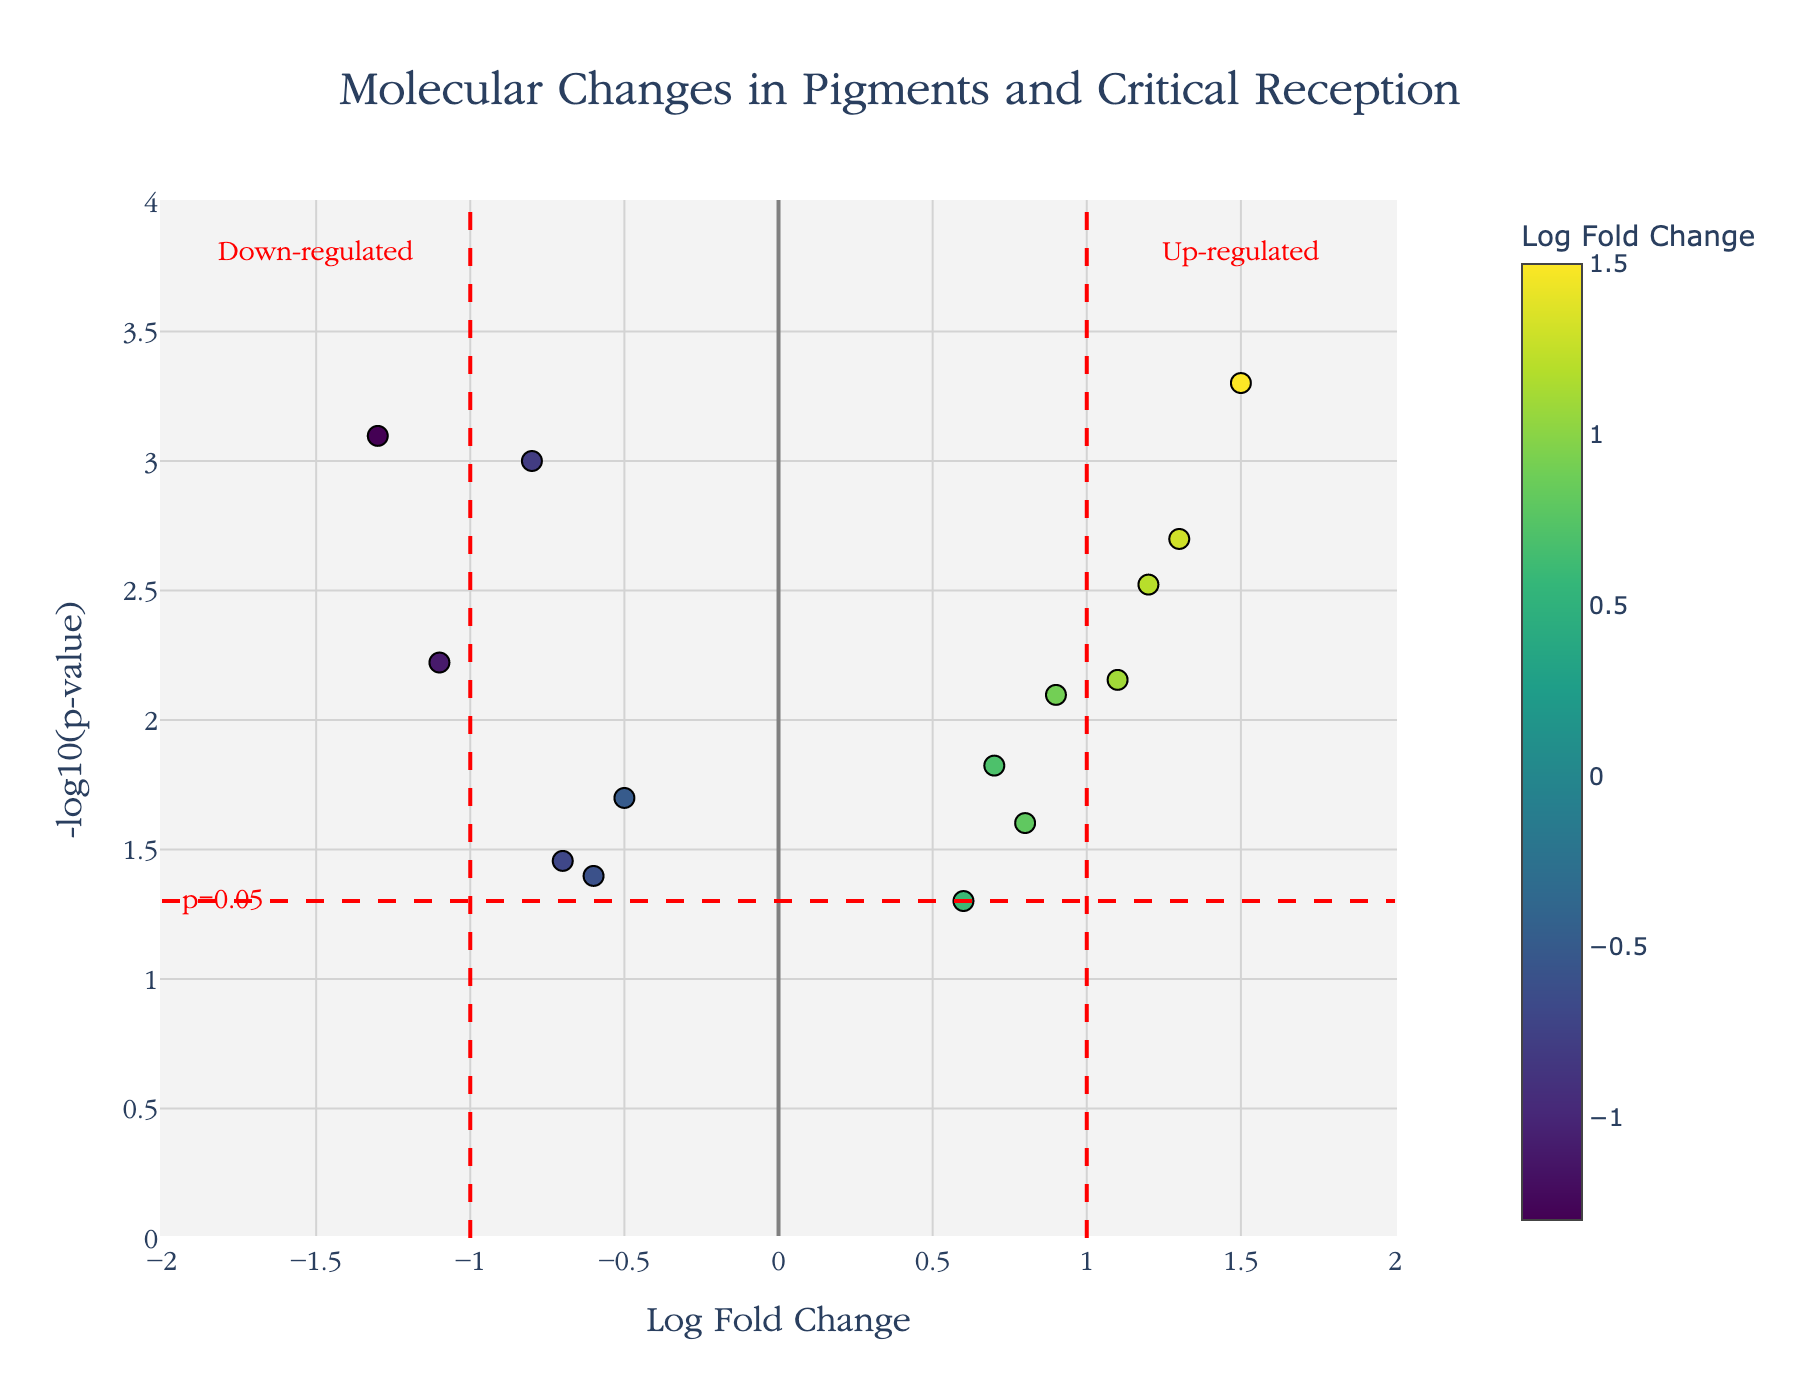what is the title of the figure? The figure's title is usually located at the top, providing an overview of what the plot represents, which helps in understanding the content and context of the visual data.
Answer: Molecular Changes in Pigments and Critical Reception How many pigments have a log fold change greater than 1? To answer this, we locate data points on the x-axis with values greater than 1. These points are highlighted by colors and hover text markers.
Answer: 4 Which pigment shows the highest average molecular change? To identify the pigment with the highest average molecular change, compare the log fold change values on the x-axis. Look for the highest positive value, which indicates the most significant average molecular change.
Answer: Ultramarine Are there any pigments with a p-value less than 0.005? Observing the y-axis, we locate points with a -log10(p-value) greater than 2.301 (-log10(0.005)), since a smaller p-value implies a higher y-axis value.
Answer: Yes Which painting by Van Gogh has pigments showing molecular changes over time? By reviewing the hover text or matching data points with the corresponding painting name in the hover details, we identify the painting associated with Van Gogh.
Answer: The Starry Night How does the presence of 'Lead White' in 'The Night Watch' by Rembrandt relate to molecular changes? Locate the 'Lead White' pigment and refer to its log fold change on the x-axis and its p-value on the y-axis to understand its molecular change over time.
Answer: Slightly down-regulated (log fold change -0.8) Which pigment in 'The Arnolfini Portrait' by Van Eyck is most down-regulated? By inspecting the hover text details for 'The Arnolfini Portrait,' identify the pigment and observe its log fold change value on the x-axis. Look for the most negative change.
Answer: Malachite What threshold on the -log10(p-value) scale indicates significant molecular changes? Refer to the horizontal red dashed line annotated 'p=0.05' to determine the threshold value on the y-axis.
Answer: 1.301 Which painting by Vermeer indicates the highest up-regulated pigment? Using the hover text or data point associated with Vermeer's painting, find the pigment with the highest positive log fold change.
Answer: Girl with a Pearl Earring How many pigments have a down-regulation beyond the significance threshold? Identify data points on the left of the -1 vertical line and above the horizontal 'p=0.05' red dashed line to count the significantly down-regulated pigments.
Answer: 2 